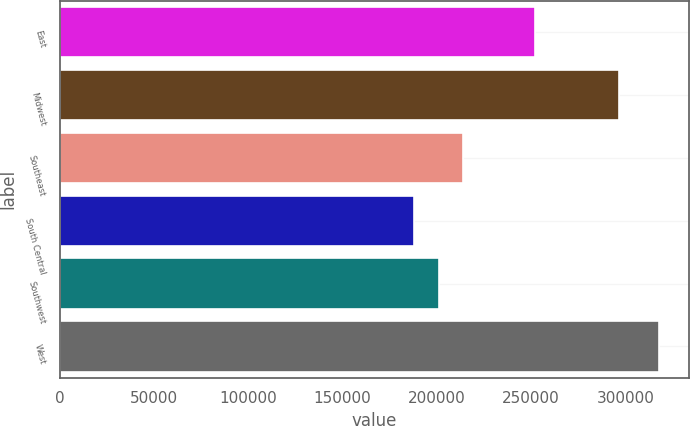Convert chart to OTSL. <chart><loc_0><loc_0><loc_500><loc_500><bar_chart><fcel>East<fcel>Midwest<fcel>Southeast<fcel>South Central<fcel>Southwest<fcel>West<nl><fcel>251900<fcel>296800<fcel>213940<fcel>188000<fcel>200970<fcel>317700<nl></chart> 